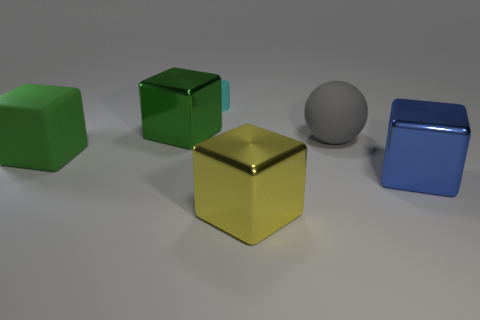Is there any other thing that has the same size as the cyan matte cylinder?
Your response must be concise. No. The small rubber cylinder is what color?
Provide a short and direct response. Cyan. There is a green cube that is in front of the big green shiny thing; is there a small object that is to the left of it?
Offer a very short reply. No. What is the shape of the tiny cyan rubber object to the left of the big block on the right side of the big gray sphere?
Make the answer very short. Cylinder. Are there fewer green metal cubes than green cubes?
Your response must be concise. Yes. Is the cyan thing made of the same material as the blue object?
Offer a terse response. No. What color is the large shiny block that is both in front of the big ball and on the left side of the big matte sphere?
Provide a short and direct response. Yellow. Are there any red metallic things that have the same size as the yellow block?
Offer a terse response. No. There is a matte cylinder behind the matte thing that is on the left side of the tiny cyan object; how big is it?
Offer a terse response. Small. Are there fewer blue metallic objects behind the large matte cube than tiny cylinders?
Keep it short and to the point. Yes. 